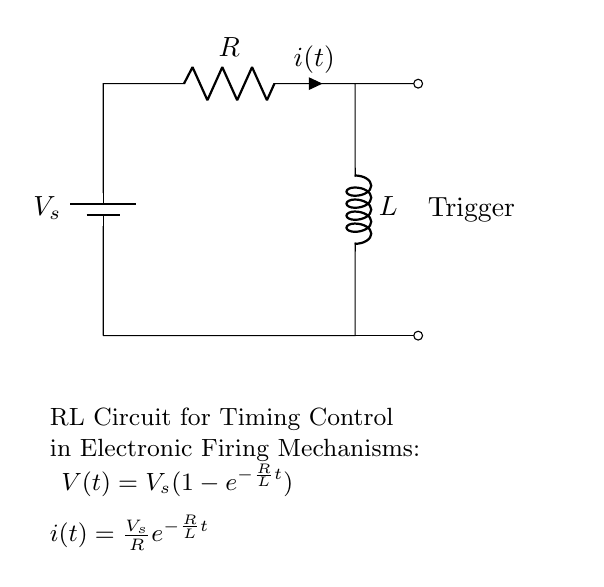What is the source voltage in the circuit? The source voltage is indicated as \(V_s\) in the diagram, which is the potential difference provided by the battery.
Answer: Vs What components are present in the circuit? The circuit contains a battery, a resistor labeled \(R\), and an inductor labeled \(L\). These components are straightforwardly identifiable from the diagram.
Answer: Battery, R, L What type of circuit is this? This is an RL circuit, which includes both a resistor and an inductor in series. The term "RL" indicates that the circuit has these specific characteristics.
Answer: RL circuit What is the current \(i(t)\) through the circuit at any time \(t\)? The current \(i(t)\) is defined by the equation \(i(t) = \frac{V_s}{R} e^{-\frac{R}{L}t}\), which represents how current changes over time in response to the voltage and resistance.
Answer: \(\frac{V_s}{R} e^{-\frac{R}{L}t}\) How does the current behave as time increases? As time increases, the term \(e^{-\frac{R}{L}t}\) exponentially decreases towards zero, which means the current will initially be high and approach zero over time.
Answer: Decreases towards zero What condition must be satisfied for the timing control in this circuit? The timing control in this circuit is governed by the time constant \(\tau = \frac{L}{R}\), which determines the rate at which current and voltage change over time.
Answer: \(L/R\) 